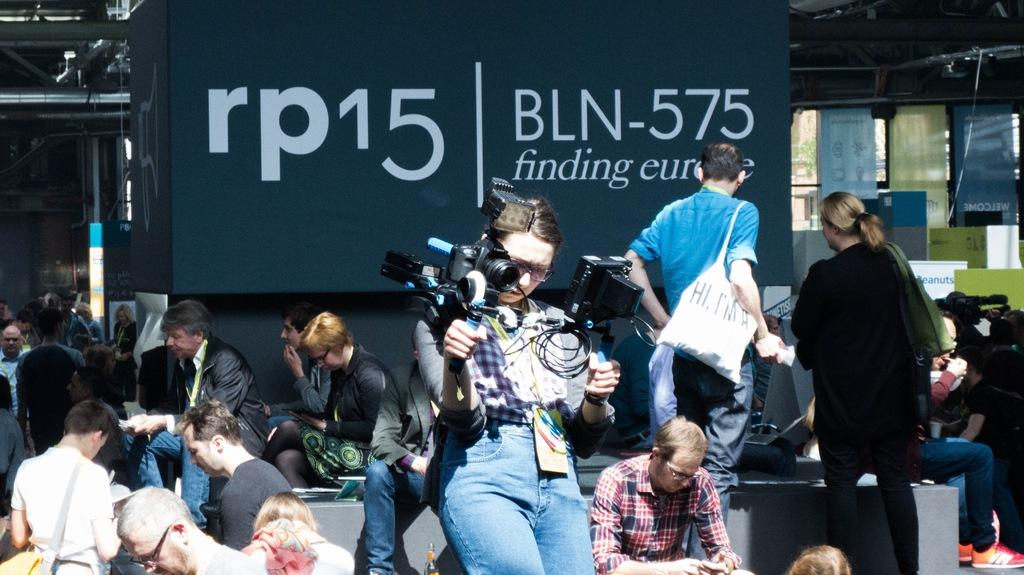How many people are in the image? There are persons in the image, but the exact number is not specified. What is the woman in the image holding? The woman is holding a camera in the image. What can be seen in the background of the image? There is a banner and boards in the background of the image. What type of bear can be seen digesting a plane in the image? There is no bear or plane present in the image. 